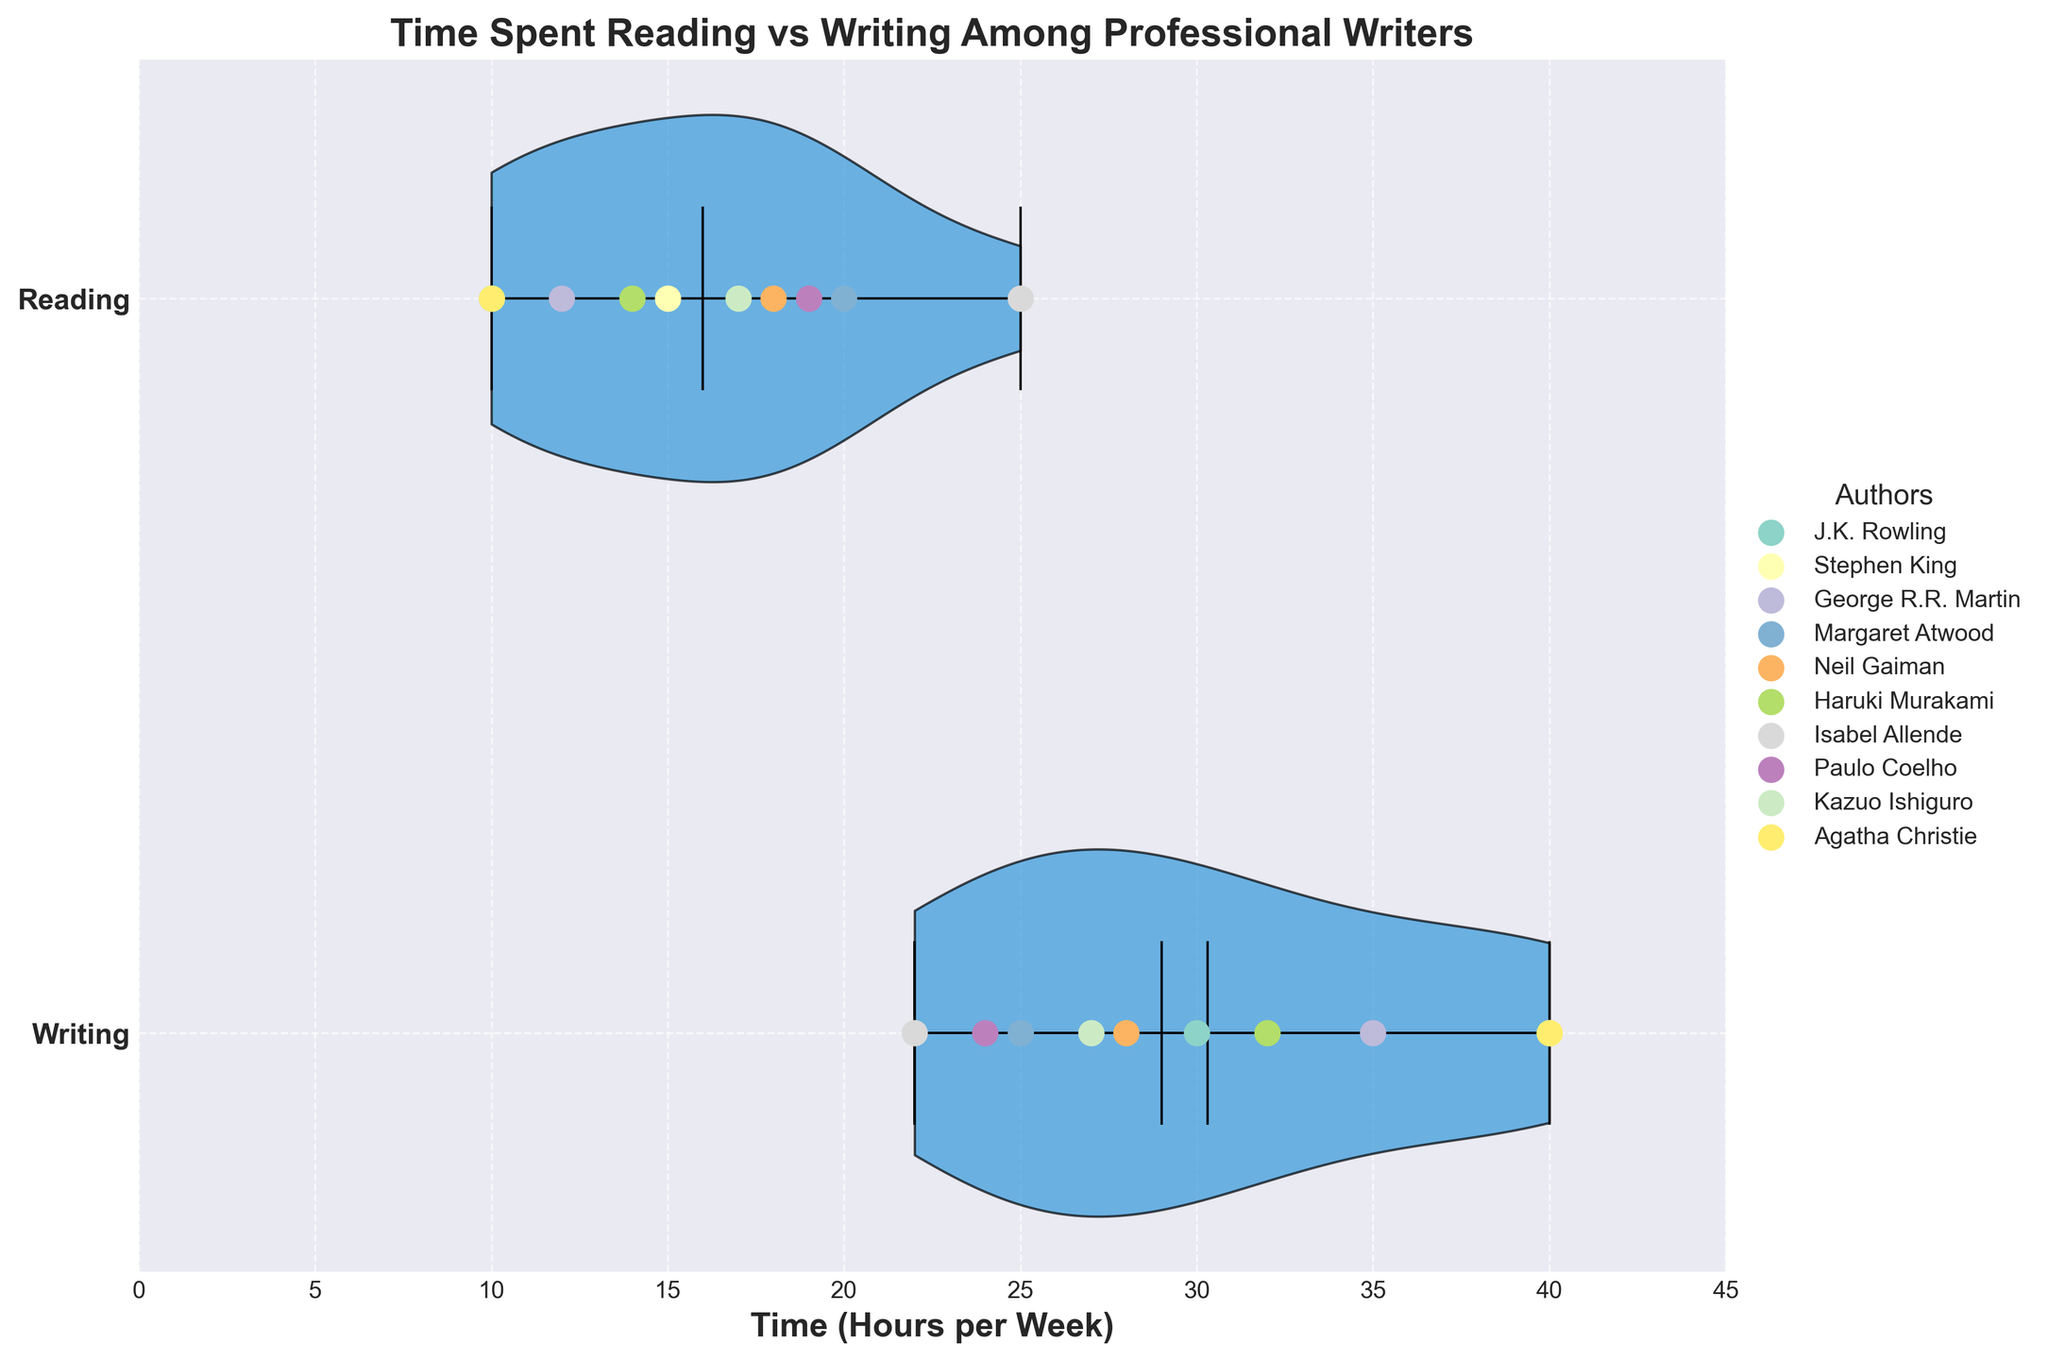How many activities are displayed for each author? There are two activities, Writing and Reading, displayed for each author on separate horizontal strips in the violin chart. This can be confirmed by seeing the scatter points corresponding to Writing and Reading for each author on the chart.
Answer: Two What is the title of the figure? The title is displayed at the top of the chart. It reads "Time Spent Reading vs Writing Among Professional Writers".
Answer: Time Spent Reading vs Writing Among Professional Writers Which activity shows more variation in time spent? By looking at the shape and spread of the violin plots, Writing has a wider spread compared to Reading. Therefore, Writing shows more variation in terms of time spent.
Answer: Writing What is the median value of the time spent writing? The median value for the time spent writing can be observed from the horizontal line inside the Writing violin plot. The median line is roughly at 29 hours per week.
Answer: 29 hours per week Which author spends the most time writing per week? By examining the scatter points on the Writing strip, Stephen King and Agatha Christie have points reaching the 40-hour mark, which is the highest time spent on writing.
Answer: Stephen King and Agatha Christie How does J.K. Rowling's time spent reading compare to her time spent writing? J.K. Rowling's data points show 10 hours per week reading and 30 hours per week writing when observed on the respective horizontal scales.
Answer: She spends more time writing Who spends more time on average, Neil Gaiman or Margaret Atwood? To determine the average for Neil Gaiman: (28 + 18)/2 = 23 hours per week. For Margaret Atwood: (25 + 20)/2 = 22.5 hours per week. Comparing these, Neil Gaiman spends slightly more on average.
Answer: Neil Gaiman What's the average time spent reading among all authors? Summing up the reading times: (10 + 15 + 12 + 20 + 18 + 14 + 25 + 19 + 17 + 10) = 160. There are 10 authors, so 160/10 = 16 hours per week.
Answer: 16 hours per week Which author's points form the greatest distance between reading and writing times? The greatest difference is found by visually comparing the distances between points in the Reading and Writing strips. J.K. Rowling has a significant distance with 30 hours writing and 10 hours reading, a 20-hour difference.
Answer: J.K. Rowling What can be concluded from the scatter layout about Haruki Murakami's writing and reading times? Haruki Murakami's scatter points show 32 hours for writing and 14 hours for reading, indicating he spends significantly more time writing than reading.
Answer: He spends significantly more time writing 